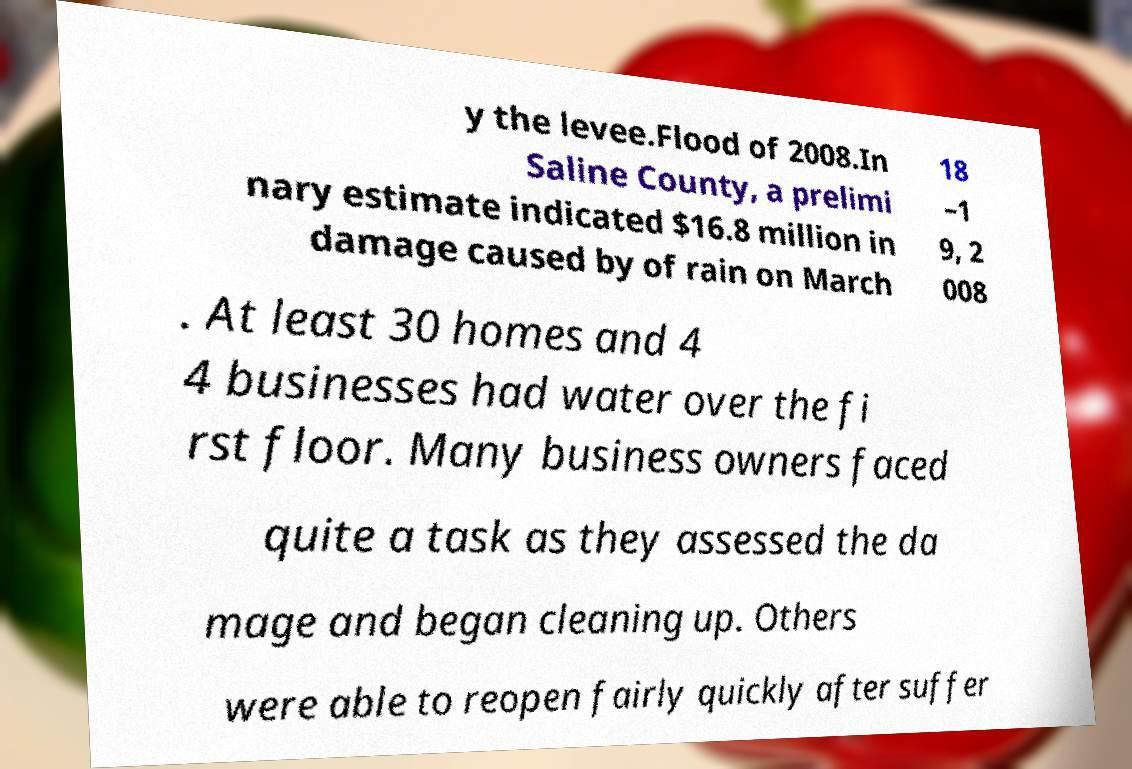There's text embedded in this image that I need extracted. Can you transcribe it verbatim? y the levee.Flood of 2008.In Saline County, a prelimi nary estimate indicated $16.8 million in damage caused by of rain on March 18 –1 9, 2 008 . At least 30 homes and 4 4 businesses had water over the fi rst floor. Many business owners faced quite a task as they assessed the da mage and began cleaning up. Others were able to reopen fairly quickly after suffer 